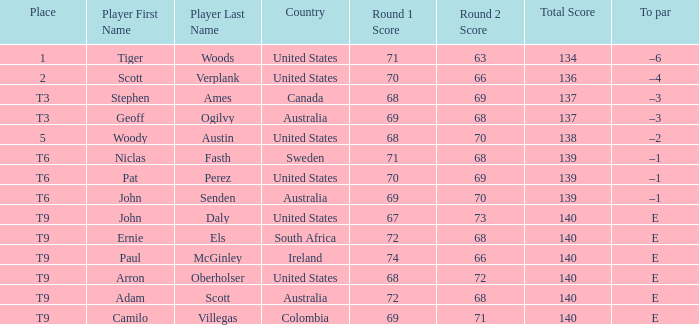What country is Adam Scott from? Australia. 